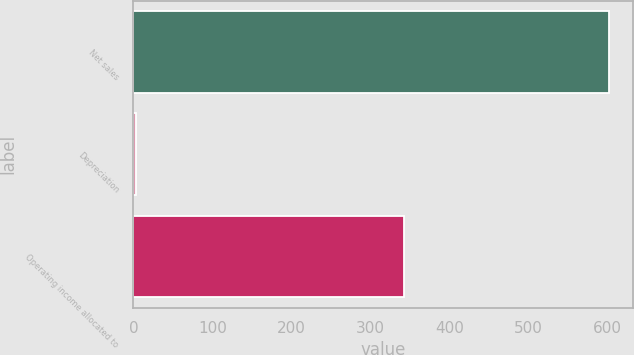Convert chart to OTSL. <chart><loc_0><loc_0><loc_500><loc_500><bar_chart><fcel>Net sales<fcel>Depreciation<fcel>Operating income allocated to<nl><fcel>602<fcel>3<fcel>343<nl></chart> 